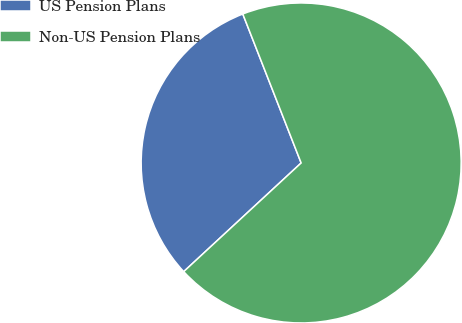Convert chart to OTSL. <chart><loc_0><loc_0><loc_500><loc_500><pie_chart><fcel>US Pension Plans<fcel>Non-US Pension Plans<nl><fcel>30.94%<fcel>69.06%<nl></chart> 